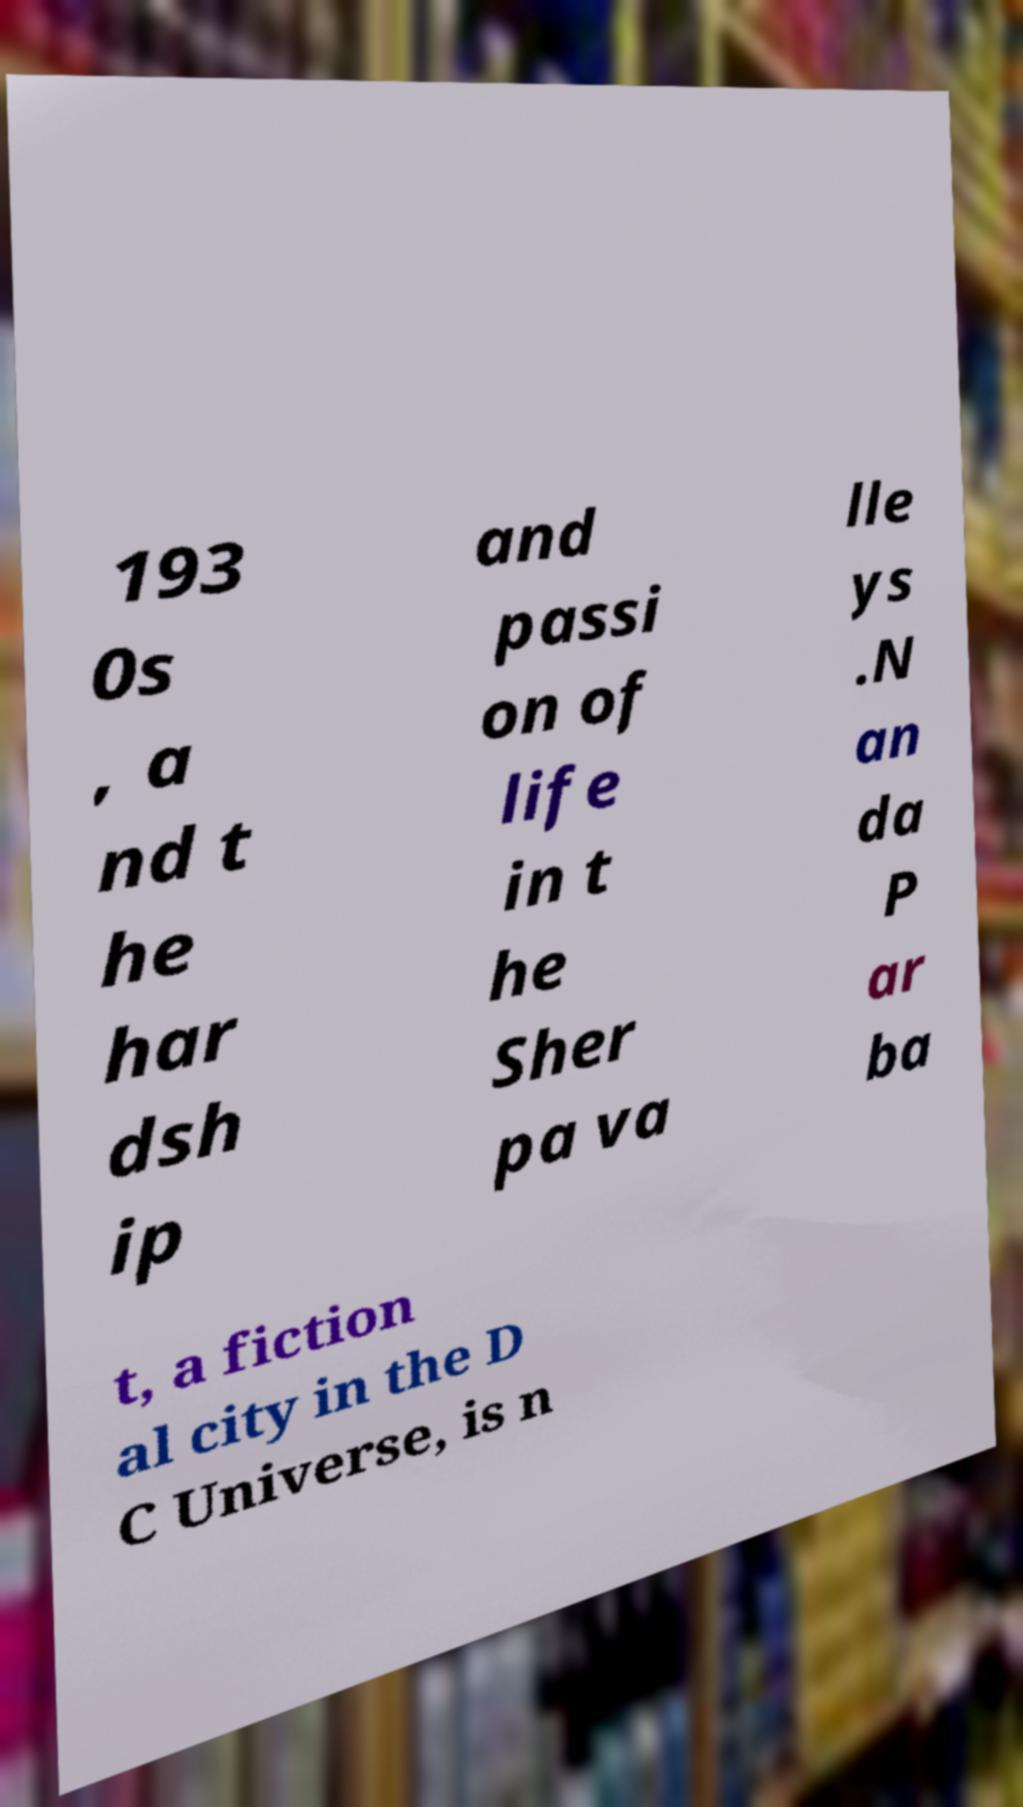Can you read and provide the text displayed in the image?This photo seems to have some interesting text. Can you extract and type it out for me? 193 0s , a nd t he har dsh ip and passi on of life in t he Sher pa va lle ys .N an da P ar ba t, a fiction al city in the D C Universe, is n 